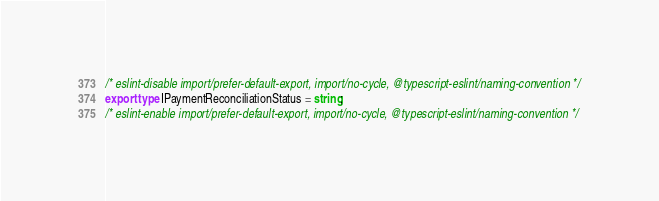<code> <loc_0><loc_0><loc_500><loc_500><_TypeScript_>/* eslint-disable import/prefer-default-export, import/no-cycle, @typescript-eslint/naming-convention */
export type IPaymentReconciliationStatus = string;
/* eslint-enable import/prefer-default-export, import/no-cycle, @typescript-eslint/naming-convention */
</code> 